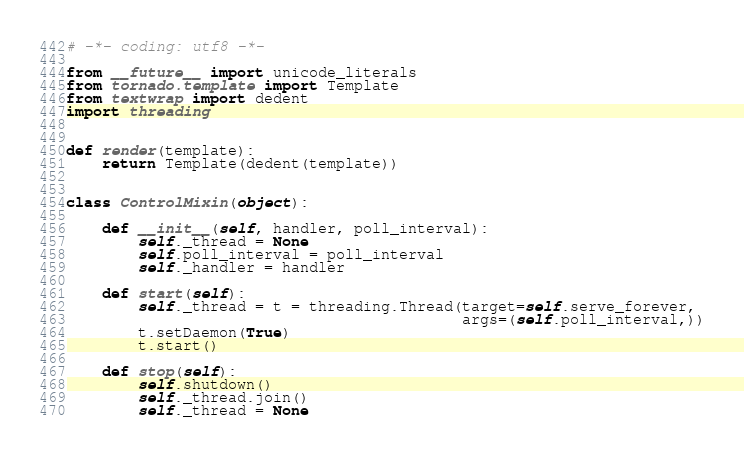<code> <loc_0><loc_0><loc_500><loc_500><_Python_># -*- coding: utf8 -*-

from __future__ import unicode_literals
from tornado.template import Template
from textwrap import dedent
import threading


def render(template):
    return Template(dedent(template))


class ControlMixin(object):

    def __init__(self, handler, poll_interval):
        self._thread = None
        self.poll_interval = poll_interval
        self._handler = handler

    def start(self):
        self._thread = t = threading.Thread(target=self.serve_forever,
                                            args=(self.poll_interval,))
        t.setDaemon(True)
        t.start()

    def stop(self):
        self.shutdown()
        self._thread.join()
        self._thread = None
</code> 